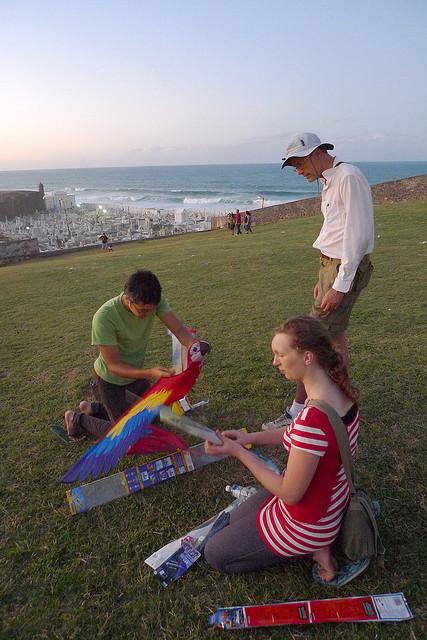What are they opening?
Be succinct. Kites. Is everyone wearing jeans?
Keep it brief. No. Are there clouds visible?
Concise answer only. No. What is the woman doing?
Be succinct. Assembling kite. Are both people reading?
Answer briefly. No. Are they in a park?
Concise answer only. Yes. What is the girl on?
Answer briefly. Grass. 